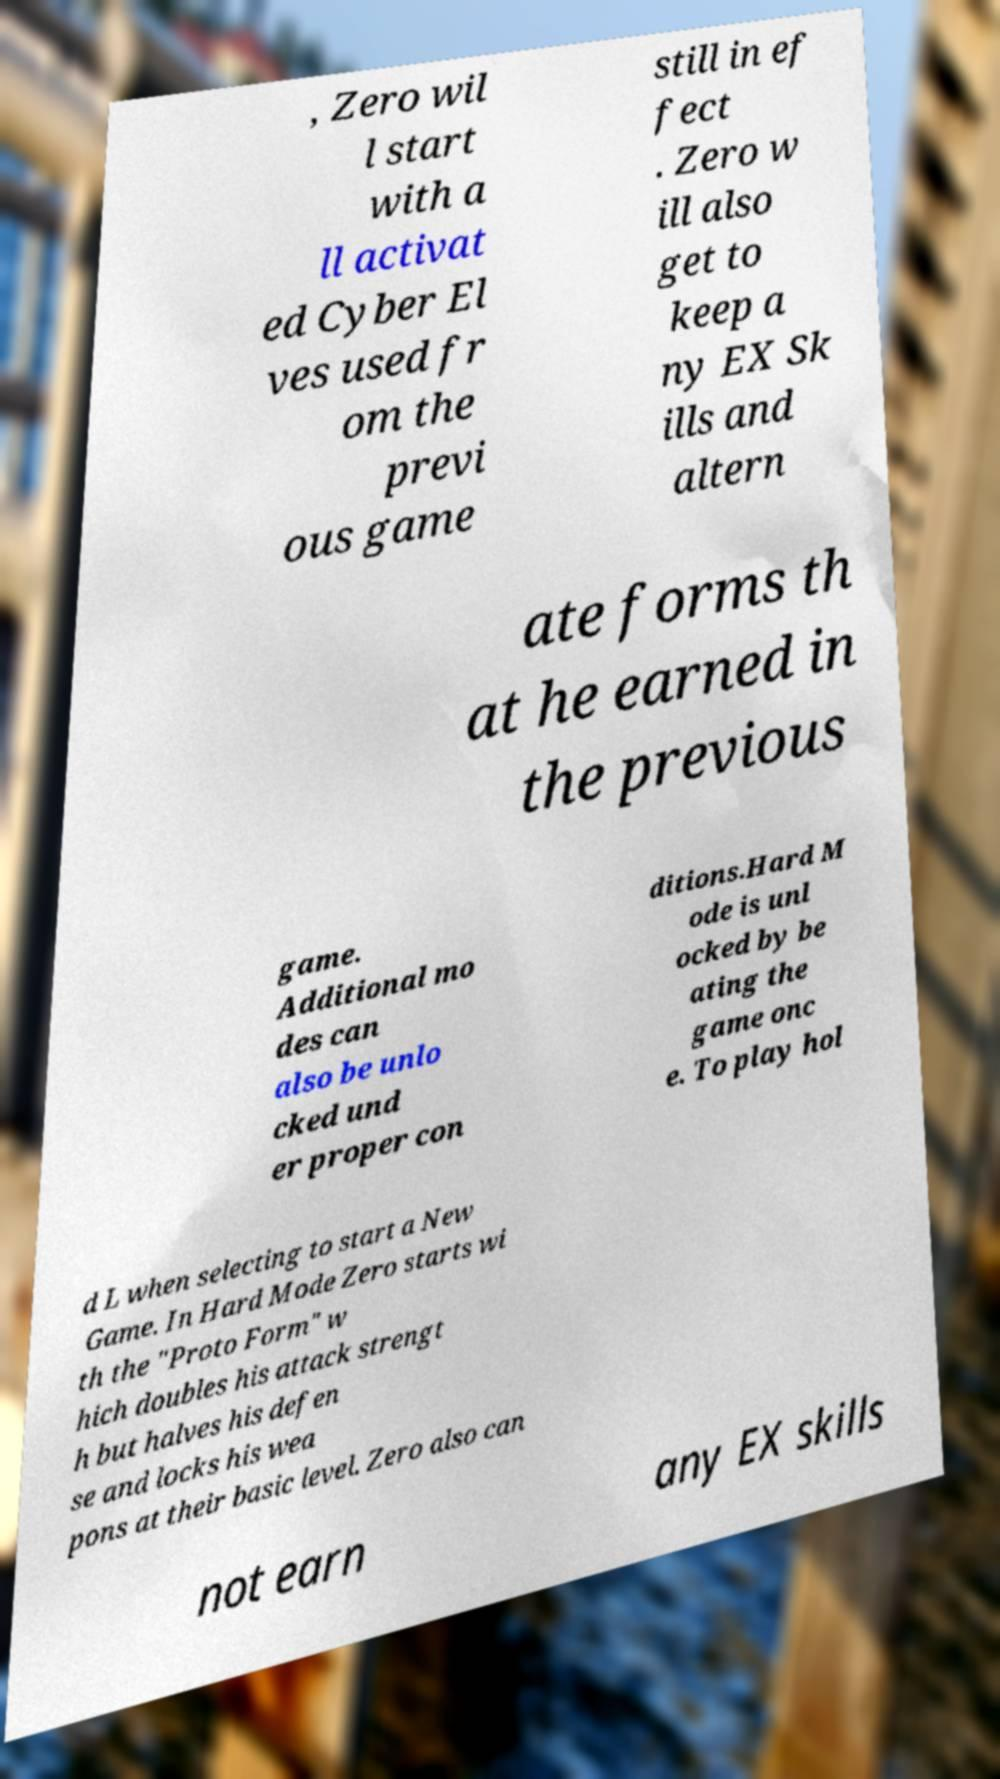Could you assist in decoding the text presented in this image and type it out clearly? , Zero wil l start with a ll activat ed Cyber El ves used fr om the previ ous game still in ef fect . Zero w ill also get to keep a ny EX Sk ills and altern ate forms th at he earned in the previous game. Additional mo des can also be unlo cked und er proper con ditions.Hard M ode is unl ocked by be ating the game onc e. To play hol d L when selecting to start a New Game. In Hard Mode Zero starts wi th the "Proto Form" w hich doubles his attack strengt h but halves his defen se and locks his wea pons at their basic level. Zero also can not earn any EX skills 